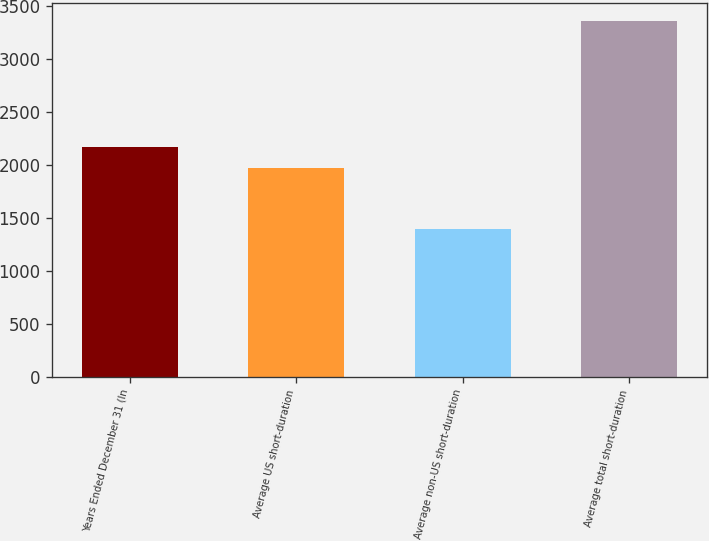<chart> <loc_0><loc_0><loc_500><loc_500><bar_chart><fcel>Years Ended December 31 (In<fcel>Average US short-duration<fcel>Average non-US short-duration<fcel>Average total short-duration<nl><fcel>2169.2<fcel>1972<fcel>1393<fcel>3365<nl></chart> 